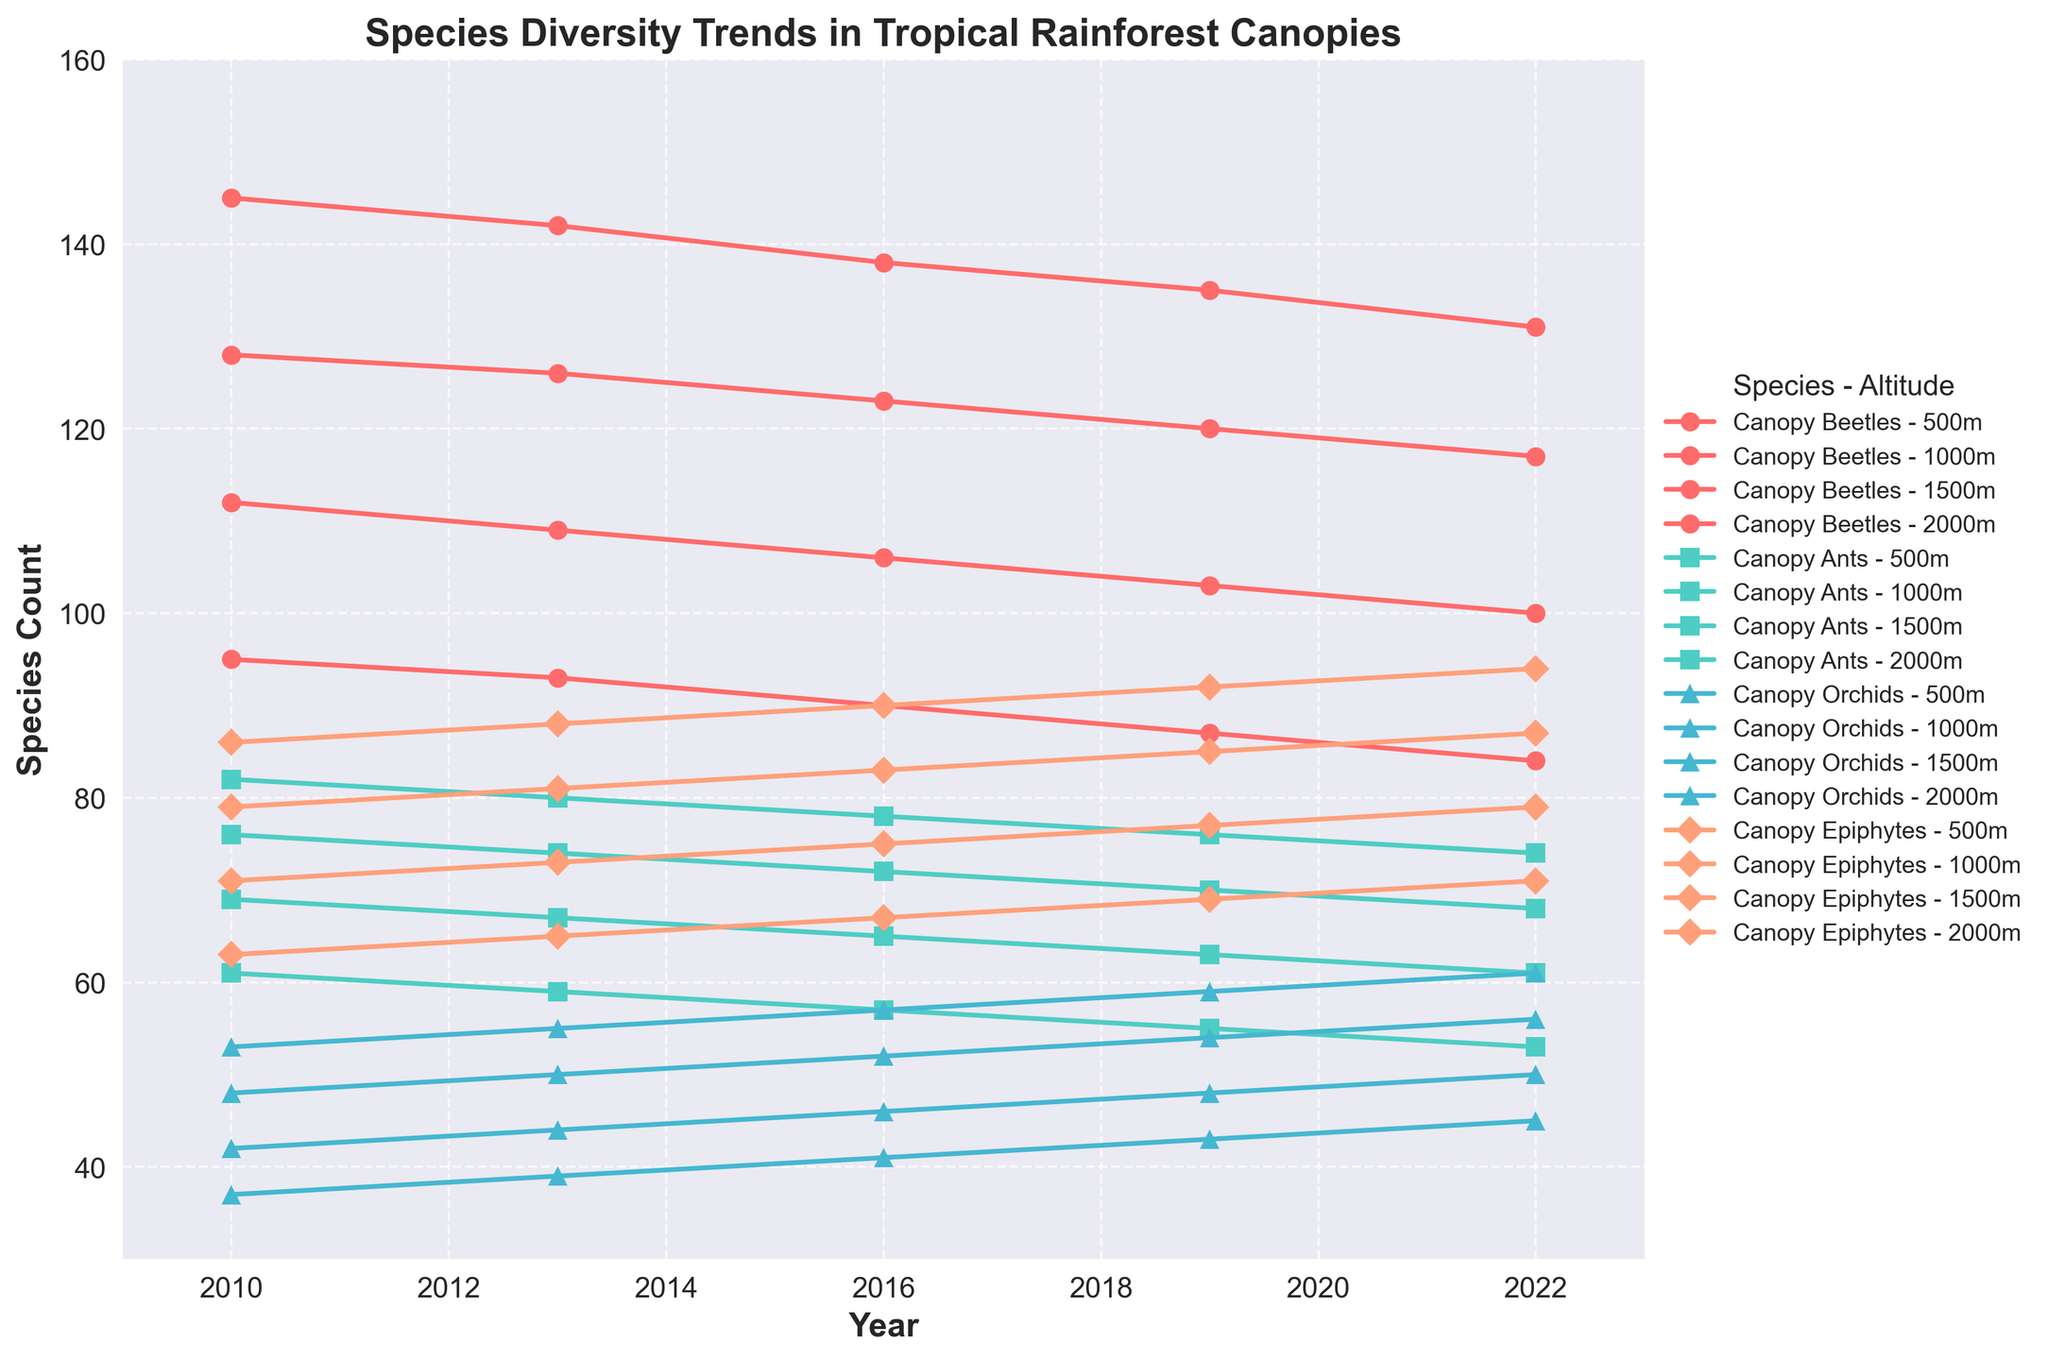Which species shows the most consistent decrease in diversity across all altitudes from 2010 to 2022? To determine the most consistent decrease, look at the trend lines for each species at all altitudes. All species show a reduction in diversity, but Canopy Beetles consistently decline more smoothly and steeply over time regardless of altitude.
Answer: Canopy Beetles At 2000 meters, how does the diversity of Canopy Orchids change from 2010 to 2022? In 2010, the number of Canopy Orchids at 2000 meters was 53, and it increased progressively to 61 by 2022. So, the difference is 61 - 53.
Answer: Increased by 8 Compare the trend lines for Canopy Epiphytes at 500 meters and 2000 meters. Which altitude shows a greater increase in species diversity from 2010 to 2022? At 500 meters, Canopy Epiphytes increase from 63 in 2010 to 71 in 2022. At 2000 meters, the numbers increase from 86 in 2010 to 94 in 2022. The increase is greater at 2000 meters (94 - 86 = 8) than at 500 meters (71 - 63 = 8).
Answer: 2000 meters Which species shows the least change in diversity at 1500 meters from 2010 to 2022? At 1500 meters, Canopy Epiphytes increase from 79 in 2010 to 87 in 2022, Canopy Orchids increase from 48 to 56, Canopy Ants decrease from 69 to 61, and Canopy Beetles decrease from 112 to 100. The least change is seen in Canopy Orchids (56 - 48).
Answer: Canopy Orchids What is the average species count of Canopy Ants at 1000 meters for the years given? Sum the counts for Canopy Ants at 1000 meters across all years and divide by the number of years. The counts are 76, 74, 72, 70, and 68. Sum = 76 + 74 + 72 + 70 + 68 = 360. Average = 360 / 5.
Answer: 72 How did the diversity of Canopy Beetles at 500 meters change between 2010 and 2019? In 2010, the count was 145. In 2019, the count was 135. The change is calculated by subtracting the 2019 count from the 2010 count.
Answer: Decreased by 10 